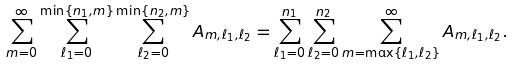<formula> <loc_0><loc_0><loc_500><loc_500>\sum _ { m = 0 } ^ { \infty } \sum _ { \ell _ { 1 } = 0 } ^ { \min \{ n _ { 1 } , m \} } \sum _ { \ell _ { 2 } = 0 } ^ { \min \{ n _ { 2 } , m \} } A _ { m , \ell _ { 1 } , \ell _ { 2 } } = \sum _ { \ell _ { 1 } = 0 } ^ { n _ { 1 } } \sum _ { \ell _ { 2 } = 0 } ^ { n _ { 2 } } \sum _ { m = \max \{ \ell _ { 1 } , \ell _ { 2 } \} } ^ { \infty } A _ { m , \ell _ { 1 } , \ell _ { 2 } } .</formula> 